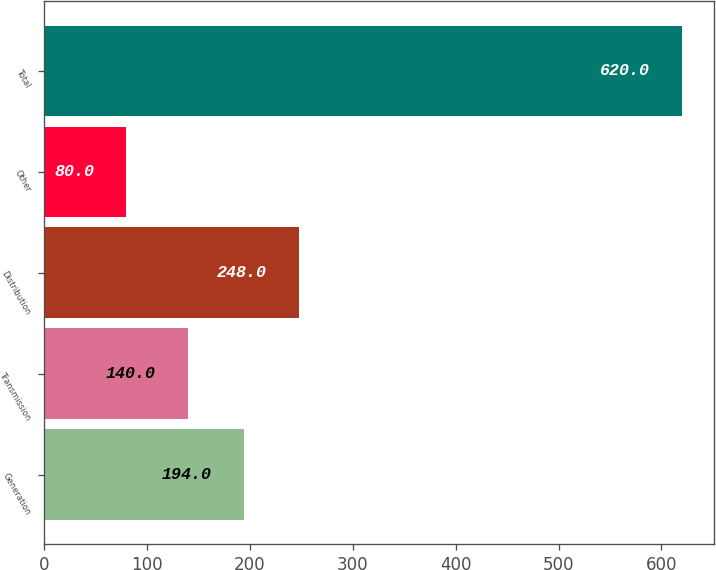<chart> <loc_0><loc_0><loc_500><loc_500><bar_chart><fcel>Generation<fcel>Transmission<fcel>Distribution<fcel>Other<fcel>Total<nl><fcel>194<fcel>140<fcel>248<fcel>80<fcel>620<nl></chart> 